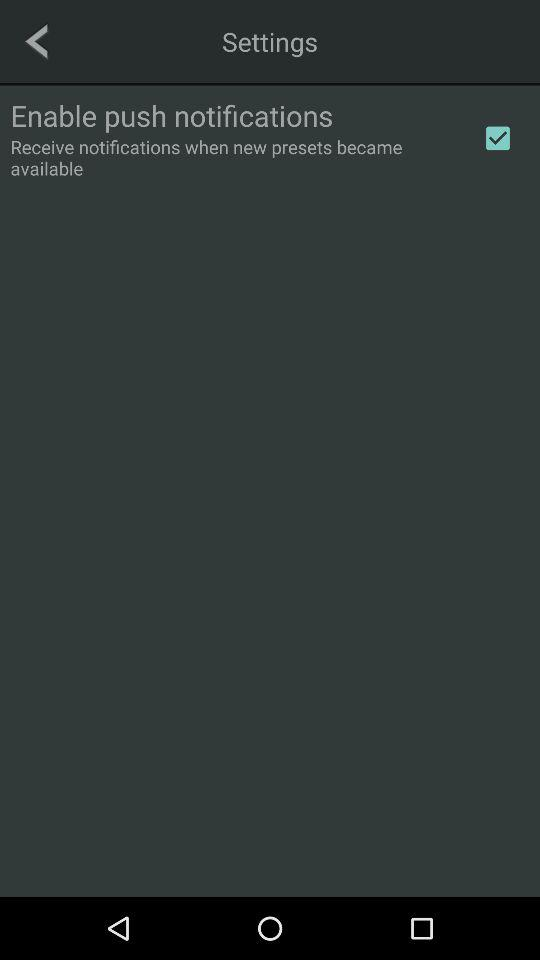What is the status of the "Enable push notifications"? The status is on. 